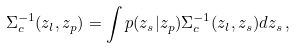<formula> <loc_0><loc_0><loc_500><loc_500>\Sigma _ { c } ^ { - 1 } ( z _ { l } , z _ { p } ) = \int p ( z _ { s } | z _ { p } ) \Sigma _ { c } ^ { - 1 } ( z _ { l } , z _ { s } ) d z _ { s } \, ,</formula> 